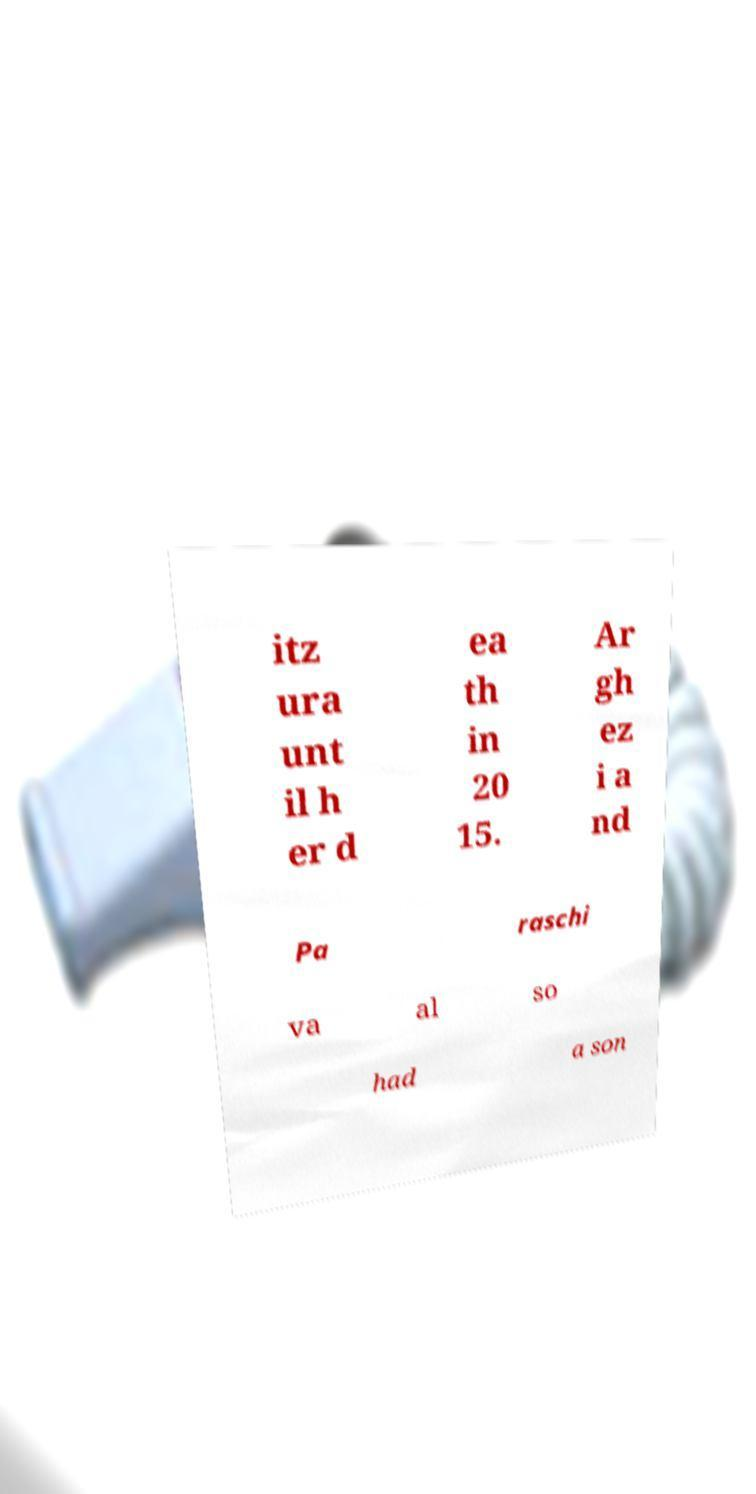Please read and relay the text visible in this image. What does it say? itz ura unt il h er d ea th in 20 15. Ar gh ez i a nd Pa raschi va al so had a son 